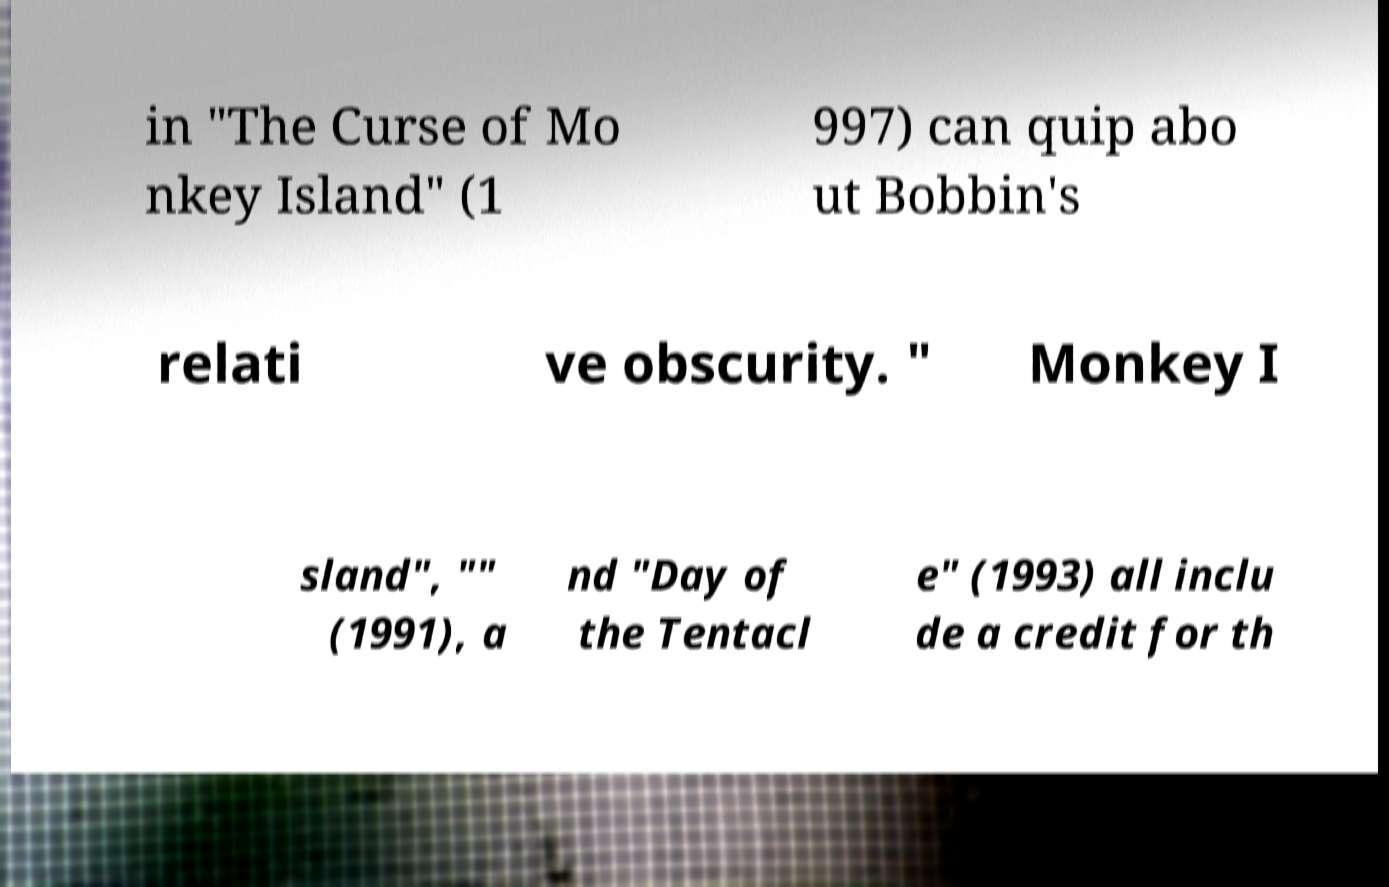Please identify and transcribe the text found in this image. in "The Curse of Mo nkey Island" (1 997) can quip abo ut Bobbin's relati ve obscurity. " Monkey I sland", "" (1991), a nd "Day of the Tentacl e" (1993) all inclu de a credit for th 